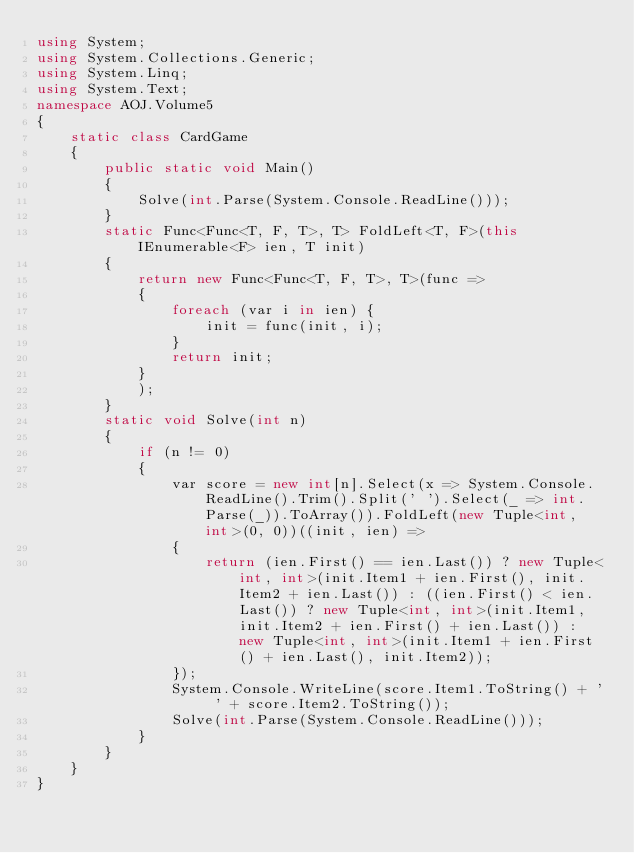<code> <loc_0><loc_0><loc_500><loc_500><_C#_>using System;
using System.Collections.Generic;
using System.Linq;
using System.Text;
namespace AOJ.Volume5
{
    static class CardGame
    {
        public static void Main()
        {
            Solve(int.Parse(System.Console.ReadLine()));
        }
        static Func<Func<T, F, T>, T> FoldLeft<T, F>(this IEnumerable<F> ien, T init)
        {
            return new Func<Func<T, F, T>, T>(func =>
            {
                foreach (var i in ien) {
                    init = func(init, i);
                }
                return init;
            }
            );
        }
        static void Solve(int n)
        {
            if (n != 0)
            {
                var score = new int[n].Select(x => System.Console.ReadLine().Trim().Split(' ').Select(_ => int.Parse(_)).ToArray()).FoldLeft(new Tuple<int, int>(0, 0))((init, ien) =>
                {
                    return (ien.First() == ien.Last()) ? new Tuple<int, int>(init.Item1 + ien.First(), init.Item2 + ien.Last()) : ((ien.First() < ien.Last()) ? new Tuple<int, int>(init.Item1, init.Item2 + ien.First() + ien.Last()) : new Tuple<int, int>(init.Item1 + ien.First() + ien.Last(), init.Item2));
                });
                System.Console.WriteLine(score.Item1.ToString() + ' ' + score.Item2.ToString());
                Solve(int.Parse(System.Console.ReadLine()));
            }
        }
    }
}</code> 